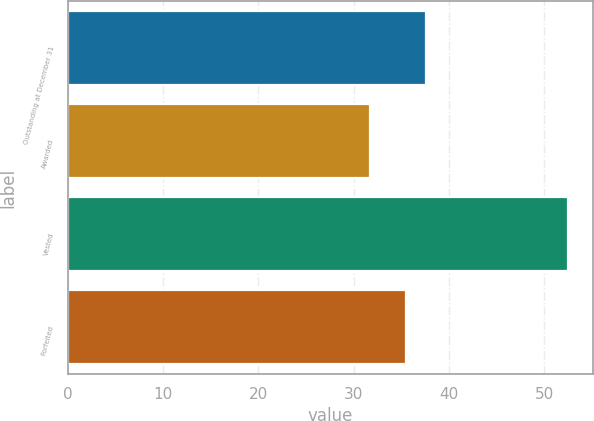Convert chart. <chart><loc_0><loc_0><loc_500><loc_500><bar_chart><fcel>Outstanding at December 31<fcel>Awarded<fcel>Vested<fcel>Forfeited<nl><fcel>37.62<fcel>31.67<fcel>52.5<fcel>35.54<nl></chart> 